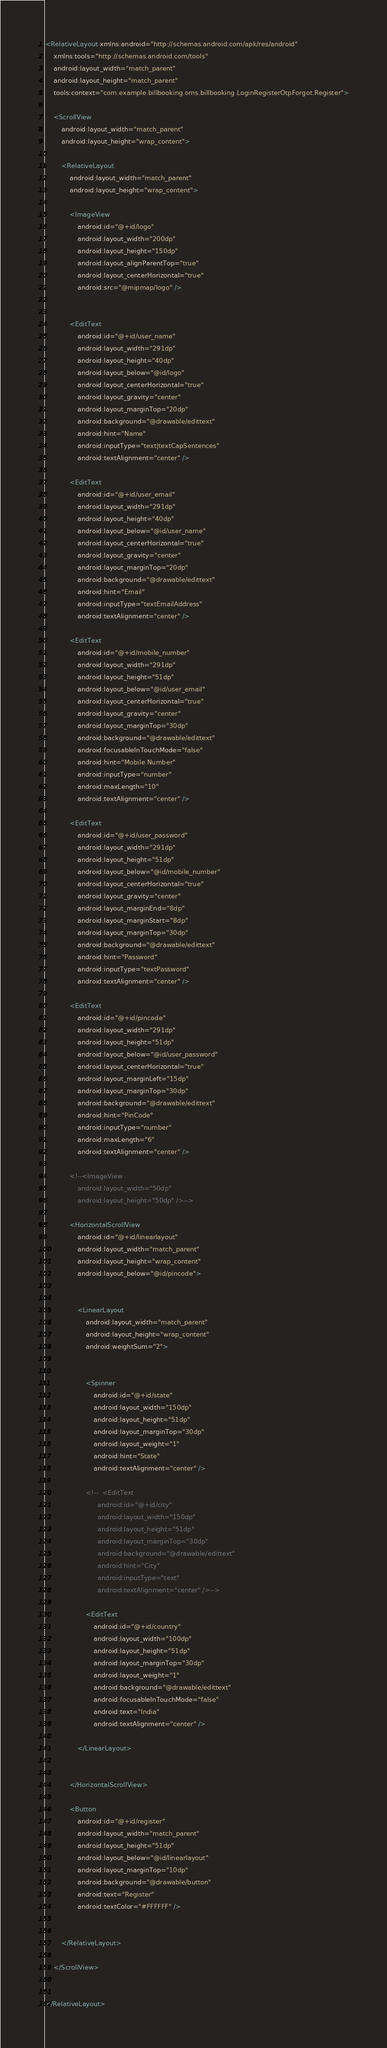Convert code to text. <code><loc_0><loc_0><loc_500><loc_500><_XML_><RelativeLayout xmlns:android="http://schemas.android.com/apk/res/android"
    xmlns:tools="http://schemas.android.com/tools"
    android:layout_width="match_parent"
    android:layout_height="match_parent"
    tools:context="com.example.billbooking.oms.billbooking.LoginRegisterOtpForgot.Register">

    <ScrollView
        android:layout_width="match_parent"
        android:layout_height="wrap_content">

        <RelativeLayout
            android:layout_width="match_parent"
            android:layout_height="wrap_content">

            <ImageView
                android:id="@+id/logo"
                android:layout_width="200dp"
                android:layout_height="150dp"
                android:layout_alignParentTop="true"
                android:layout_centerHorizontal="true"
                android:src="@mipmap/logo" />


            <EditText
                android:id="@+id/user_name"
                android:layout_width="291dp"
                android:layout_height="40dp"
                android:layout_below="@id/logo"
                android:layout_centerHorizontal="true"
                android:layout_gravity="center"
                android:layout_marginTop="20dp"
                android:background="@drawable/edittext"
                android:hint="Name"
                android:inputType="text|textCapSentences"
                android:textAlignment="center" />

            <EditText
                android:id="@+id/user_email"
                android:layout_width="291dp"
                android:layout_height="40dp"
                android:layout_below="@id/user_name"
                android:layout_centerHorizontal="true"
                android:layout_gravity="center"
                android:layout_marginTop="20dp"
                android:background="@drawable/edittext"
                android:hint="Email"
                android:inputType="textEmailAddress"
                android:textAlignment="center" />

            <EditText
                android:id="@+id/mobile_number"
                android:layout_width="291dp"
                android:layout_height="51dp"
                android:layout_below="@id/user_email"
                android:layout_centerHorizontal="true"
                android:layout_gravity="center"
                android:layout_marginTop="30dp"
                android:background="@drawable/edittext"
                android:focusableInTouchMode="false"
                android:hint="Mobile Number"
                android:inputType="number"
                android:maxLength="10"
                android:textAlignment="center" />

            <EditText
                android:id="@+id/user_password"
                android:layout_width="291dp"
                android:layout_height="51dp"
                android:layout_below="@id/mobile_number"
                android:layout_centerHorizontal="true"
                android:layout_gravity="center"
                android:layout_marginEnd="8dp"
                android:layout_marginStart="8dp"
                android:layout_marginTop="30dp"
                android:background="@drawable/edittext"
                android:hint="Password"
                android:inputType="textPassword"
                android:textAlignment="center" />

            <EditText
                android:id="@+id/pincode"
                android:layout_width="291dp"
                android:layout_height="51dp"
                android:layout_below="@id/user_password"
                android:layout_centerHorizontal="true"
                android:layout_marginLeft="15dp"
                android:layout_marginTop="30dp"
                android:background="@drawable/edittext"
                android:hint="PinCode"
                android:inputType="number"
                android:maxLength="6"
                android:textAlignment="center" />

            <!--<ImageView
                android:layout_width="50dp"
                android:layout_height="50dp" />-->

            <HorizontalScrollView
                android:id="@+id/linearlayout"
                android:layout_width="match_parent"
                android:layout_height="wrap_content"
                android:layout_below="@id/pincode">


                <LinearLayout
                    android:layout_width="match_parent"
                    android:layout_height="wrap_content"
                    android:weightSum="2">


                    <Spinner
                        android:id="@+id/state"
                        android:layout_width="150dp"
                        android:layout_height="51dp"
                        android:layout_marginTop="30dp"
                        android:layout_weight="1"
                        android:hint="State"
                        android:textAlignment="center" />

                    <!--  <EditText
                          android:id="@+id/city"
                          android:layout_width="150dp"
                          android:layout_height="51dp"
                          android:layout_marginTop="30dp"
                          android:background="@drawable/edittext"
                          android:hint="City"
                          android:inputType="text"
                          android:textAlignment="center" />-->

                    <EditText
                        android:id="@+id/country"
                        android:layout_width="100dp"
                        android:layout_height="51dp"
                        android:layout_marginTop="30dp"
                        android:layout_weight="1"
                        android:background="@drawable/edittext"
                        android:focusableInTouchMode="false"
                        android:text="India"
                        android:textAlignment="center" />

                </LinearLayout>


            </HorizontalScrollView>

            <Button
                android:id="@+id/register"
                android:layout_width="match_parent"
                android:layout_height="51dp"
                android:layout_below="@id/linearlayout"
                android:layout_marginTop="10dp"
                android:background="@drawable/button"
                android:text="Register"
                android:textColor="#FFFFFF" />


        </RelativeLayout>

    </ScrollView>


</RelativeLayout></code> 